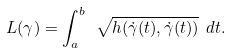<formula> <loc_0><loc_0><loc_500><loc_500>L ( \gamma ) = \int _ { a } ^ { b } \ \sqrt { h ( \dot { \gamma } ( t ) , \dot { \gamma } ( t ) ) } \ d t .</formula> 